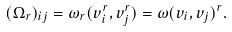<formula> <loc_0><loc_0><loc_500><loc_500>( \Omega _ { r } ) _ { i j } = \omega _ { r } ( v _ { i } ^ { r } , v _ { j } ^ { r } ) = \omega ( v _ { i } , v _ { j } ) ^ { r } .</formula> 